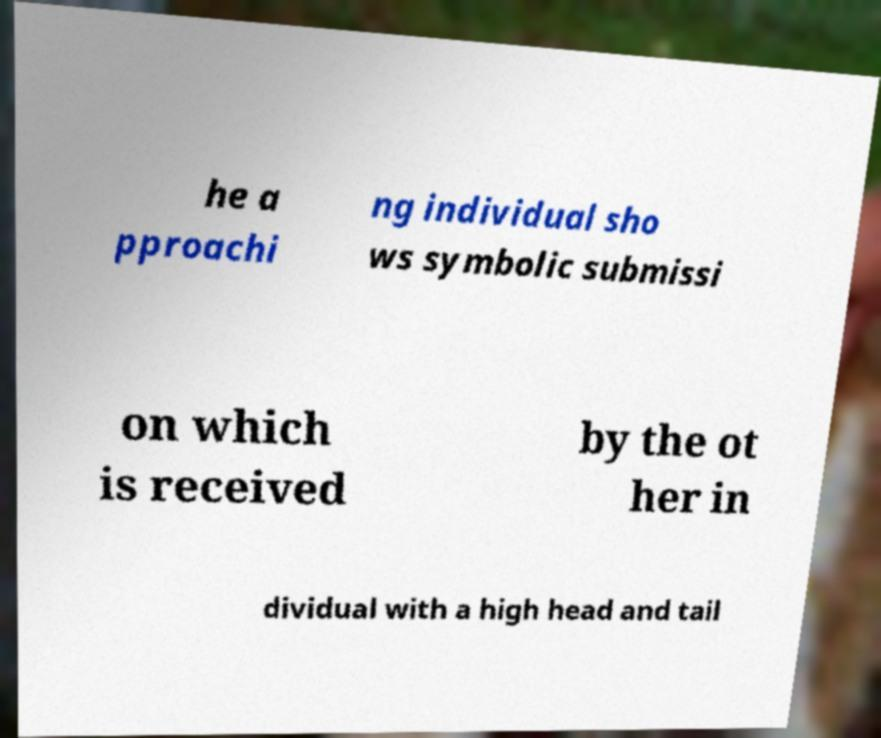Can you accurately transcribe the text from the provided image for me? he a pproachi ng individual sho ws symbolic submissi on which is received by the ot her in dividual with a high head and tail 